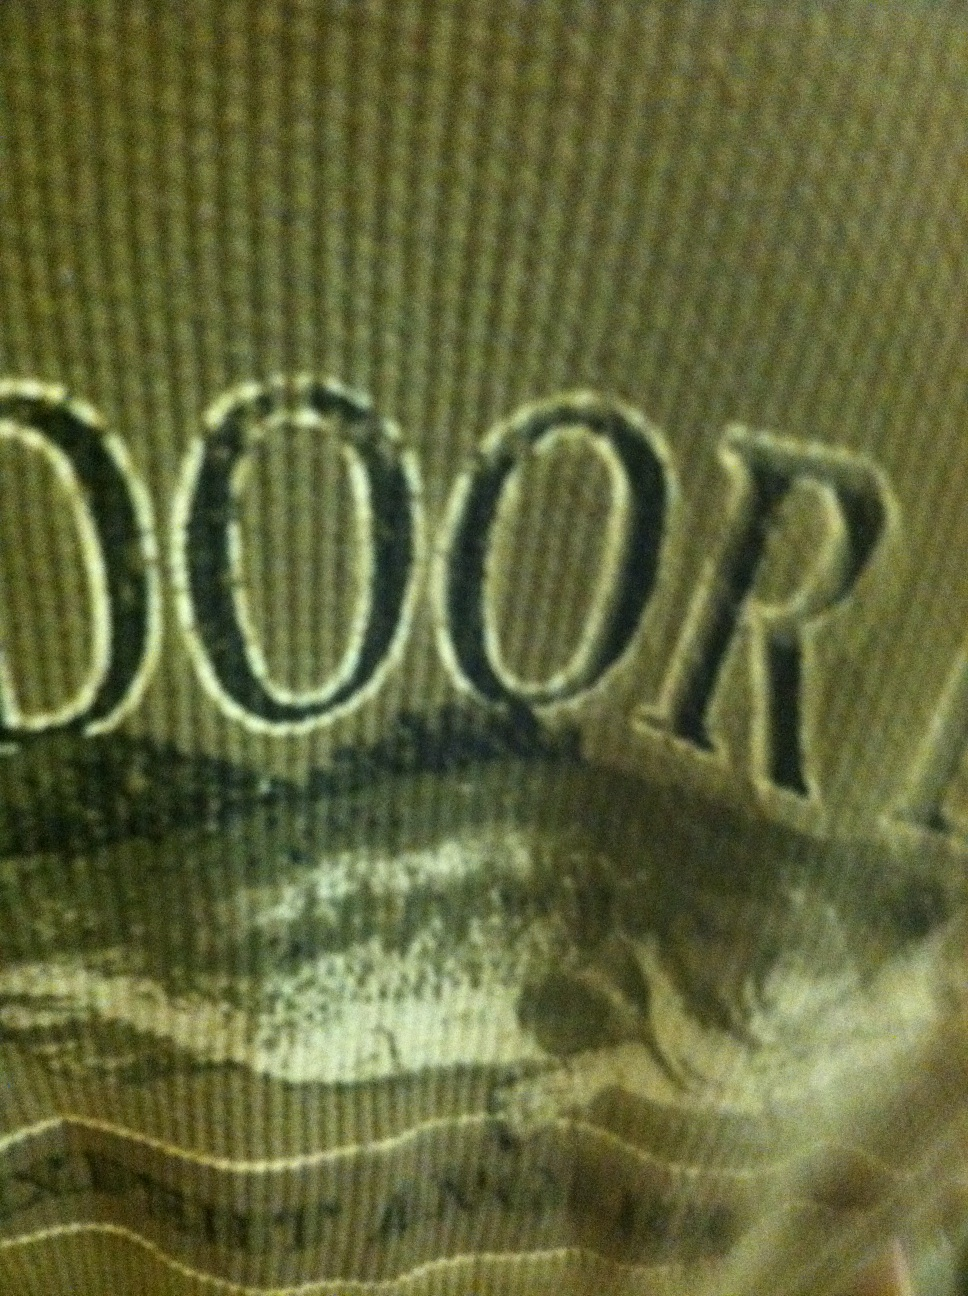What is written on this shirt? The shirt has the word 'OUTDOOR' prominently written on it, suggesting it might be designed for outdoor activities or brands. 